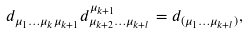<formula> <loc_0><loc_0><loc_500><loc_500>d _ { \mu _ { 1 } \dots \mu _ { k } \mu _ { k + 1 } } d ^ { \mu _ { k + 1 } } _ { \mu _ { k + 2 } \dots \mu _ { k + l } } = d _ { ( \mu _ { 1 } \dots \mu _ { k + l } ) } ,</formula> 